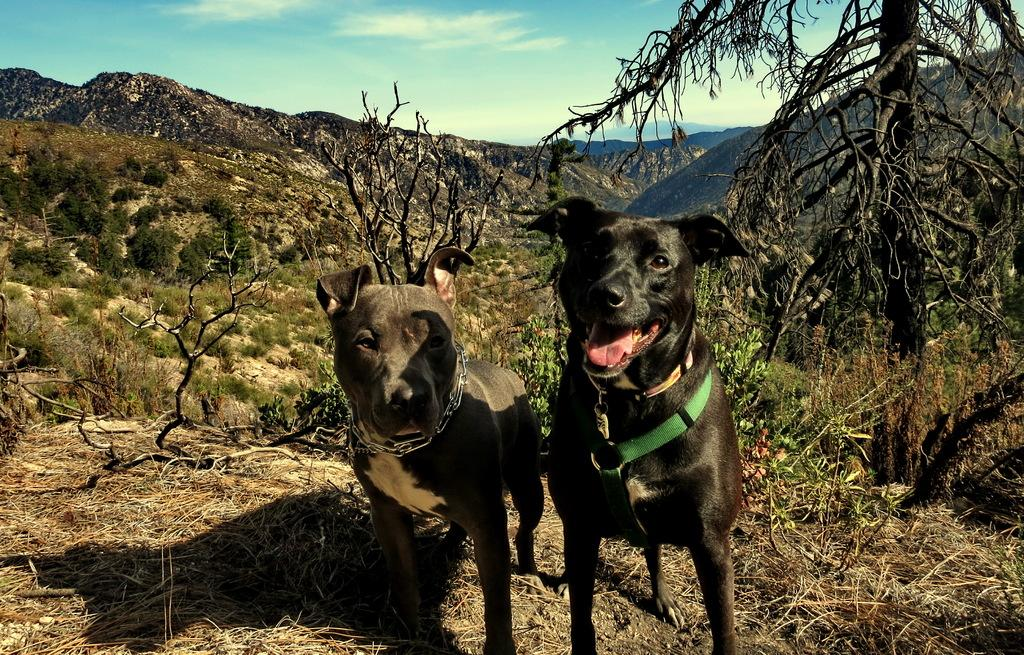How many dogs are present in the image? There are two dogs in the image. Where are the dogs located? The dogs are on the ground. What can be seen in the background of the image? There are trees, mountains, and the sky visible in the background of the image. What type of notebook is the dog holding in the image? There is no notebook present in the image; the dogs are not holding any objects. 